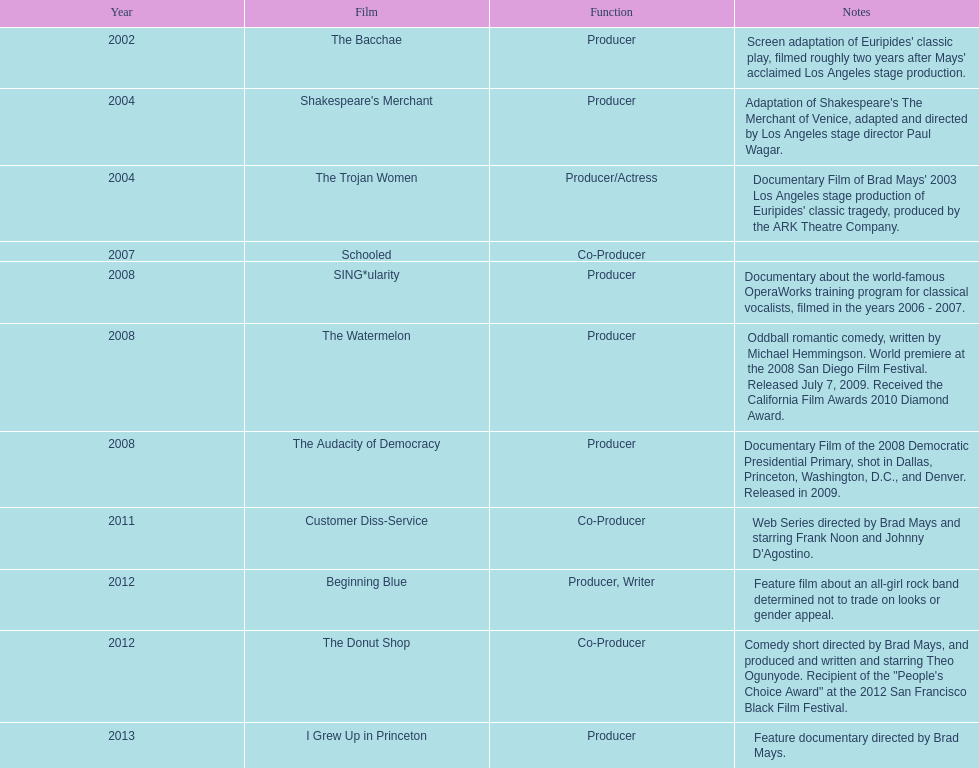What documentary motion picture was made before 2011 but following 2008? The Audacity of Democracy. 